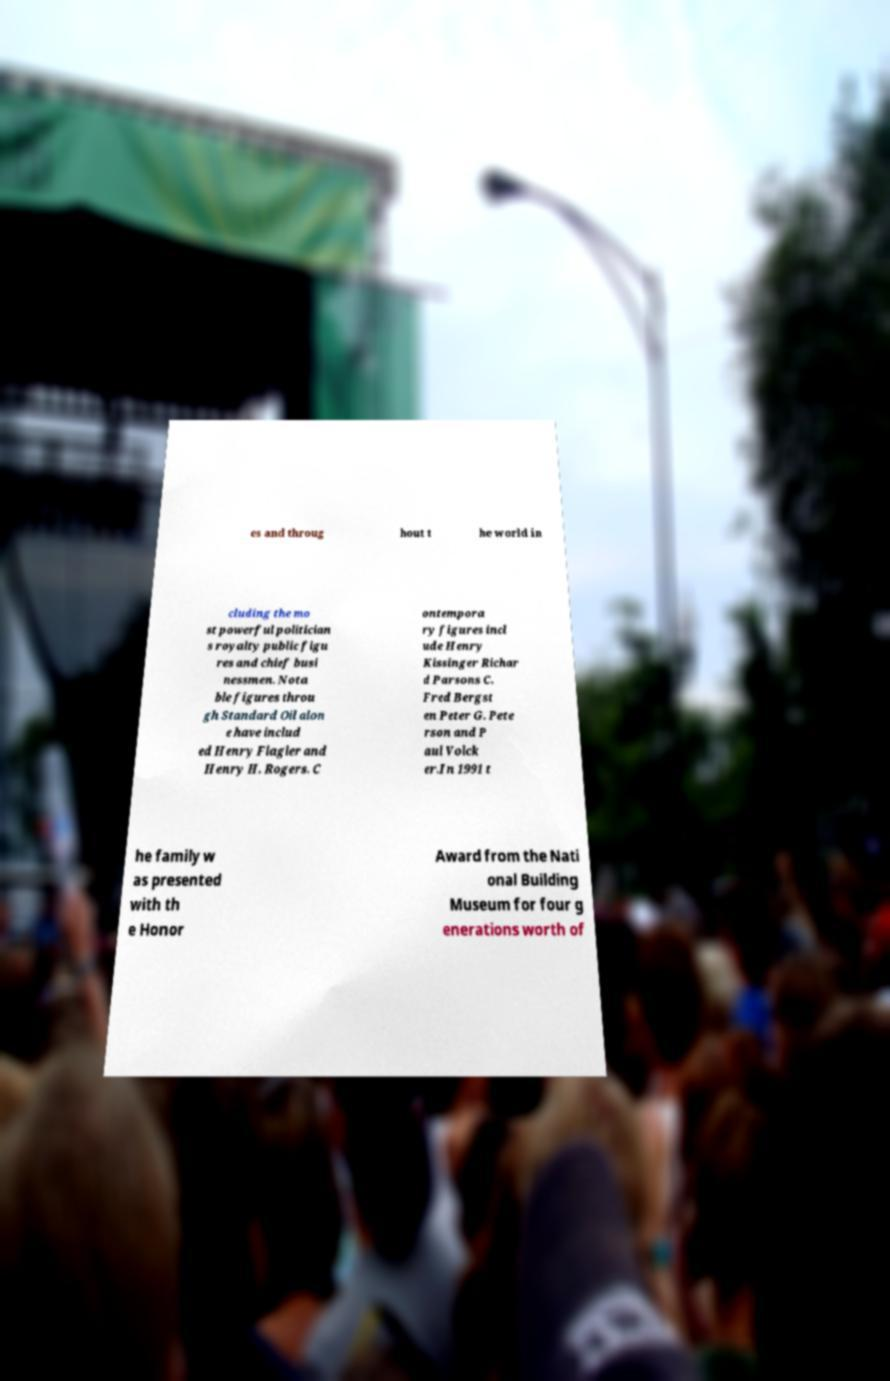Can you accurately transcribe the text from the provided image for me? es and throug hout t he world in cluding the mo st powerful politician s royalty public figu res and chief busi nessmen. Nota ble figures throu gh Standard Oil alon e have includ ed Henry Flagler and Henry H. Rogers. C ontempora ry figures incl ude Henry Kissinger Richar d Parsons C. Fred Bergst en Peter G. Pete rson and P aul Volck er.In 1991 t he family w as presented with th e Honor Award from the Nati onal Building Museum for four g enerations worth of 